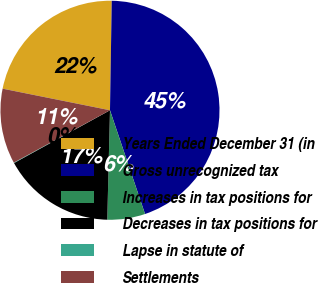<chart> <loc_0><loc_0><loc_500><loc_500><pie_chart><fcel>Years Ended December 31 (in<fcel>Gross unrecognized tax<fcel>Increases in tax positions for<fcel>Decreases in tax positions for<fcel>Lapse in statute of<fcel>Settlements<nl><fcel>22.1%<fcel>44.56%<fcel>5.58%<fcel>16.6%<fcel>0.07%<fcel>11.09%<nl></chart> 